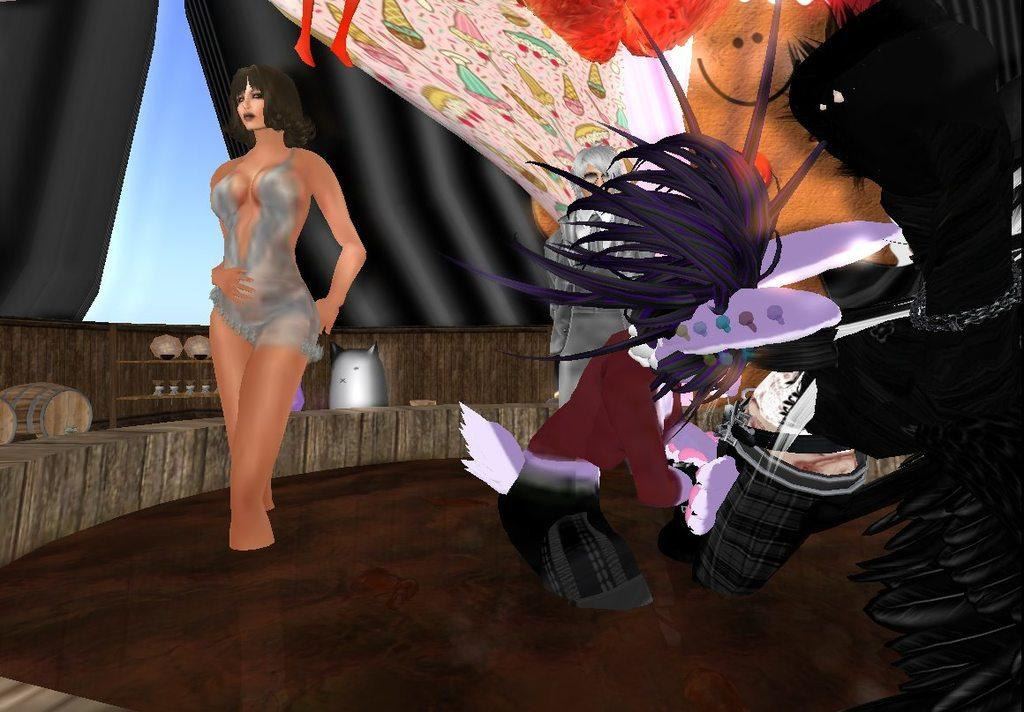What type of image is being described? The image is animated. What can be seen moving or interacting in the image? There are people in the image. What type of object is present in the image? There is a barrel in the image. What type of covering is present in the image? There are curtains in the image. What else can be seen in the image besides the people, barrel, and curtains? There are objects in the image. What can be seen in the distance or background of the image? The sky is visible in the background of the image. What type of plastic material can be seen melting in the image? There is no plastic material present in the image, nor is anything melting. 